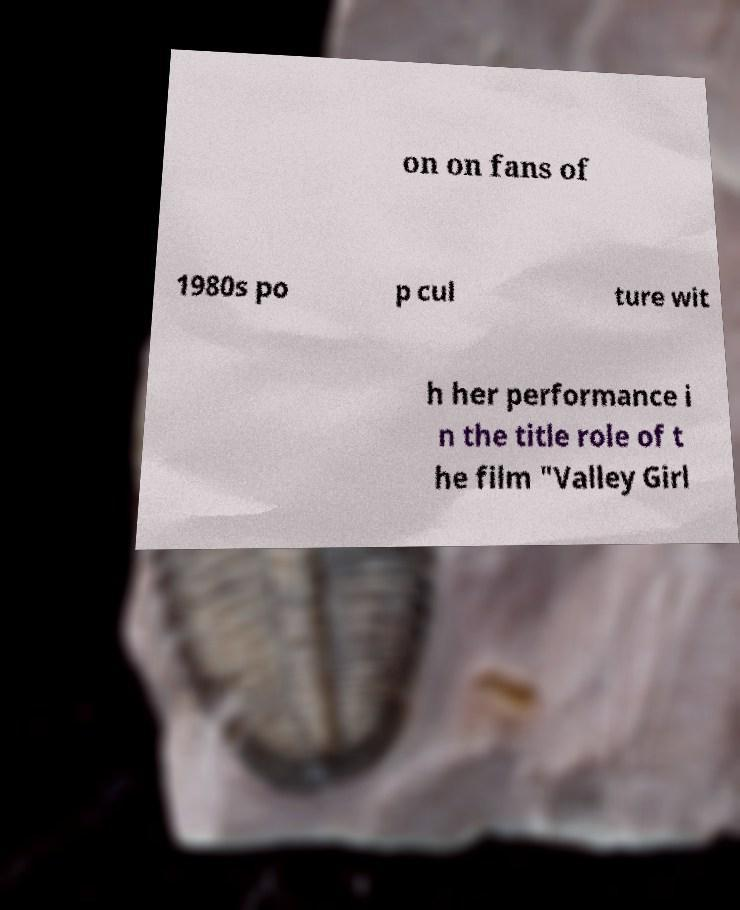There's text embedded in this image that I need extracted. Can you transcribe it verbatim? on on fans of 1980s po p cul ture wit h her performance i n the title role of t he film "Valley Girl 